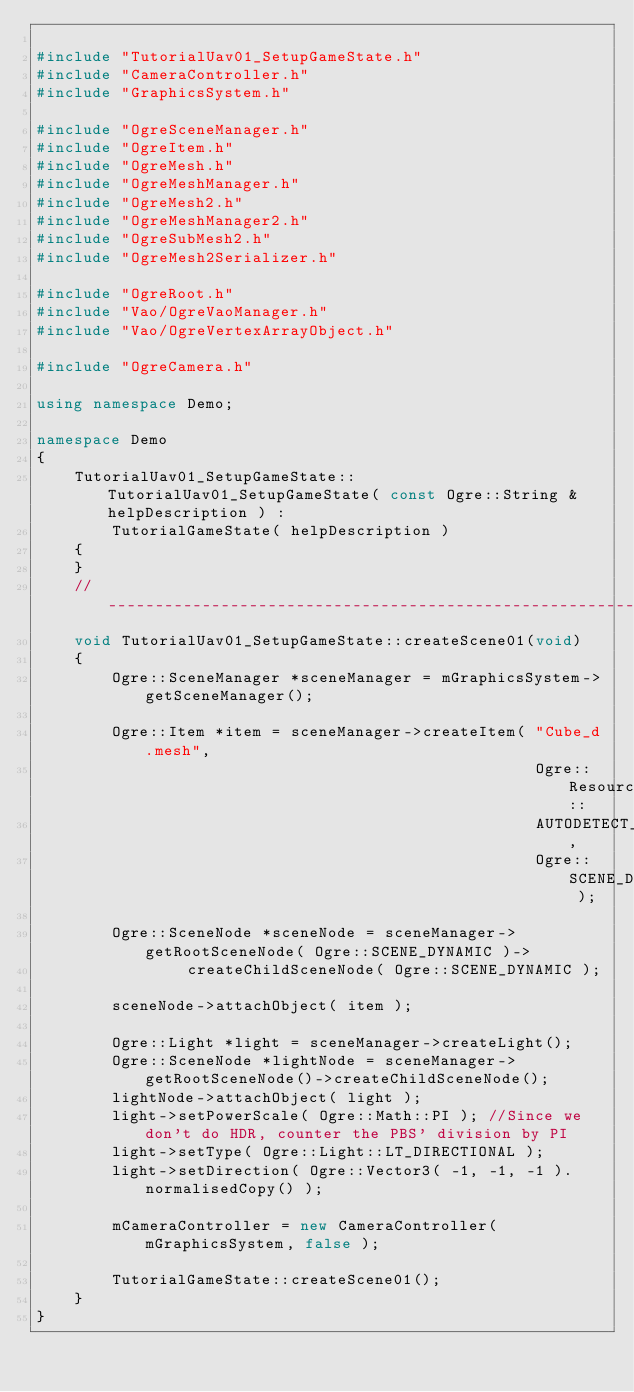<code> <loc_0><loc_0><loc_500><loc_500><_C++_>
#include "TutorialUav01_SetupGameState.h"
#include "CameraController.h"
#include "GraphicsSystem.h"

#include "OgreSceneManager.h"
#include "OgreItem.h"
#include "OgreMesh.h"
#include "OgreMeshManager.h"
#include "OgreMesh2.h"
#include "OgreMeshManager2.h"
#include "OgreSubMesh2.h"
#include "OgreMesh2Serializer.h"

#include "OgreRoot.h"
#include "Vao/OgreVaoManager.h"
#include "Vao/OgreVertexArrayObject.h"

#include "OgreCamera.h"

using namespace Demo;

namespace Demo
{
    TutorialUav01_SetupGameState::TutorialUav01_SetupGameState( const Ogre::String &helpDescription ) :
        TutorialGameState( helpDescription )
    {
    }
    //-----------------------------------------------------------------------------------
    void TutorialUav01_SetupGameState::createScene01(void)
    {
        Ogre::SceneManager *sceneManager = mGraphicsSystem->getSceneManager();

        Ogre::Item *item = sceneManager->createItem( "Cube_d.mesh",
                                                     Ogre::ResourceGroupManager::
                                                     AUTODETECT_RESOURCE_GROUP_NAME,
                                                     Ogre::SCENE_DYNAMIC );

        Ogre::SceneNode *sceneNode = sceneManager->getRootSceneNode( Ogre::SCENE_DYNAMIC )->
                createChildSceneNode( Ogre::SCENE_DYNAMIC );

        sceneNode->attachObject( item );

        Ogre::Light *light = sceneManager->createLight();
        Ogre::SceneNode *lightNode = sceneManager->getRootSceneNode()->createChildSceneNode();
        lightNode->attachObject( light );
        light->setPowerScale( Ogre::Math::PI ); //Since we don't do HDR, counter the PBS' division by PI
        light->setType( Ogre::Light::LT_DIRECTIONAL );
        light->setDirection( Ogre::Vector3( -1, -1, -1 ).normalisedCopy() );

        mCameraController = new CameraController( mGraphicsSystem, false );

        TutorialGameState::createScene01();
    }
}
</code> 